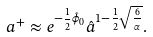Convert formula to latex. <formula><loc_0><loc_0><loc_500><loc_500>a ^ { + } \approx e ^ { - \frac { 1 } { 2 } \hat { \phi } _ { 0 } } \hat { a } ^ { 1 - \frac { 1 } { 2 } \sqrt { \frac { 6 } { \alpha } } } .</formula> 